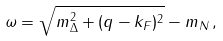Convert formula to latex. <formula><loc_0><loc_0><loc_500><loc_500>\omega = \sqrt { m _ { \Delta } ^ { 2 } + ( q - k _ { F } ) ^ { 2 } } - m _ { N } \, ,</formula> 